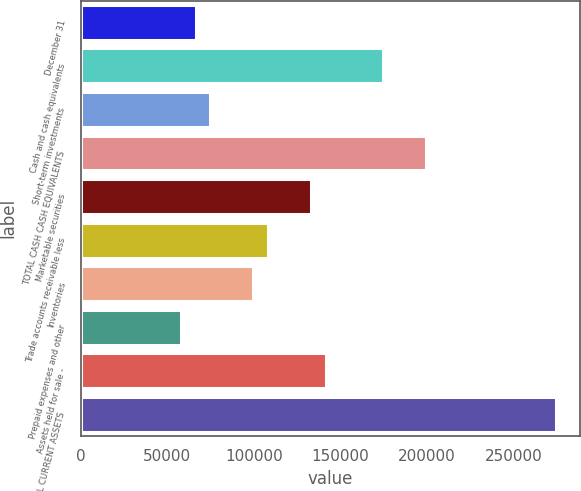<chart> <loc_0><loc_0><loc_500><loc_500><bar_chart><fcel>December 31<fcel>Cash and cash equivalents<fcel>Short-term investments<fcel>TOTAL CASH CASH EQUIVALENTS<fcel>Marketable securities<fcel>Trade accounts receivable less<fcel>Inventories<fcel>Prepaid expenses and other<fcel>Assets held for sale -<fcel>TOTAL CURRENT ASSETS<nl><fcel>66583<fcel>174698<fcel>74899.5<fcel>199647<fcel>133115<fcel>108166<fcel>99849<fcel>58266.5<fcel>141432<fcel>274496<nl></chart> 